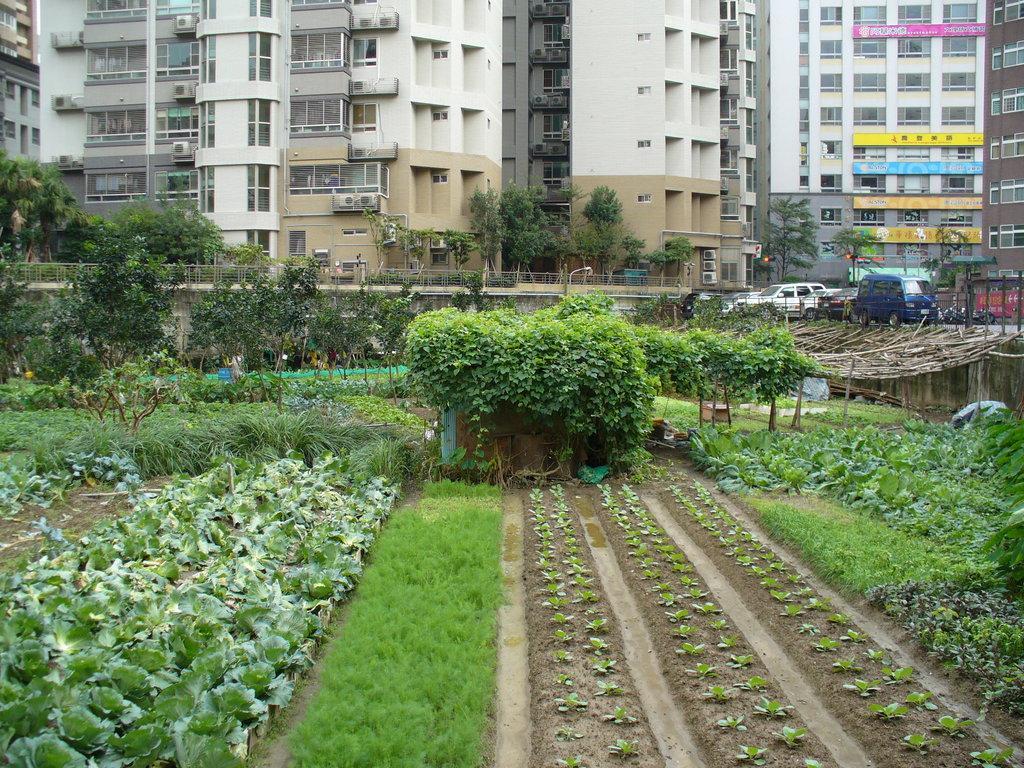How would you summarize this image in a sentence or two? In this image we can see buildings, air conditioners, road, iron grill, motor vehicles on the road, trees, plants, shrubs, bushes, grass and creepers. 